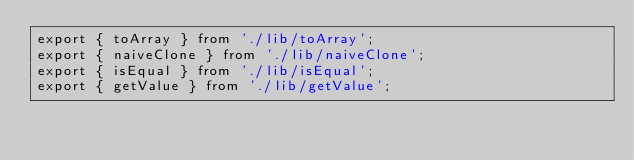Convert code to text. <code><loc_0><loc_0><loc_500><loc_500><_TypeScript_>export { toArray } from './lib/toArray';
export { naiveClone } from './lib/naiveClone';
export { isEqual } from './lib/isEqual';
export { getValue } from './lib/getValue';
</code> 